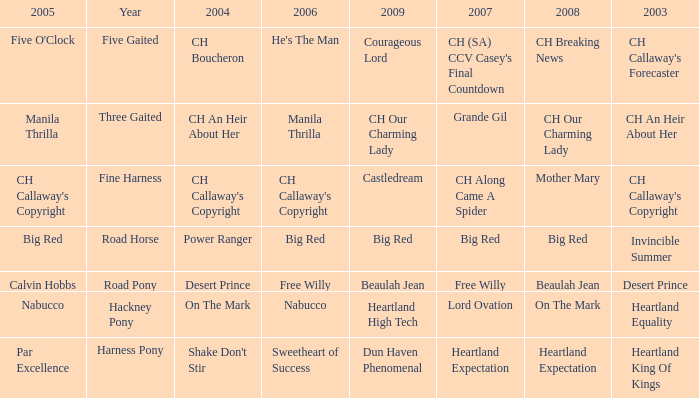What is the 2007 for the 2003 desert prince? Free Willy. 